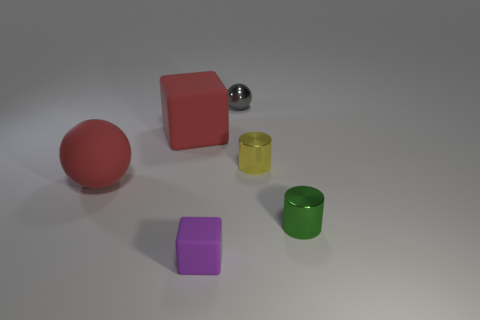Does the large matte cube have the same color as the tiny metallic ball?
Your answer should be compact. No. The matte object that is the same color as the big cube is what shape?
Offer a terse response. Sphere. How many things are cubes that are behind the purple rubber object or small objects in front of the gray metal sphere?
Offer a very short reply. 4. What is the shape of the gray thing that is made of the same material as the yellow object?
Ensure brevity in your answer.  Sphere. Is there anything else of the same color as the big block?
Provide a short and direct response. Yes. What is the material of the other red object that is the same shape as the tiny matte object?
Your answer should be compact. Rubber. What number of other things are the same size as the yellow object?
Ensure brevity in your answer.  3. What material is the tiny cube?
Ensure brevity in your answer.  Rubber. Are there more tiny green cylinders that are left of the purple rubber thing than large blocks?
Provide a short and direct response. No. Are any brown metallic cylinders visible?
Your answer should be compact. No. 